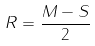<formula> <loc_0><loc_0><loc_500><loc_500>R = \frac { M - S } { 2 }</formula> 